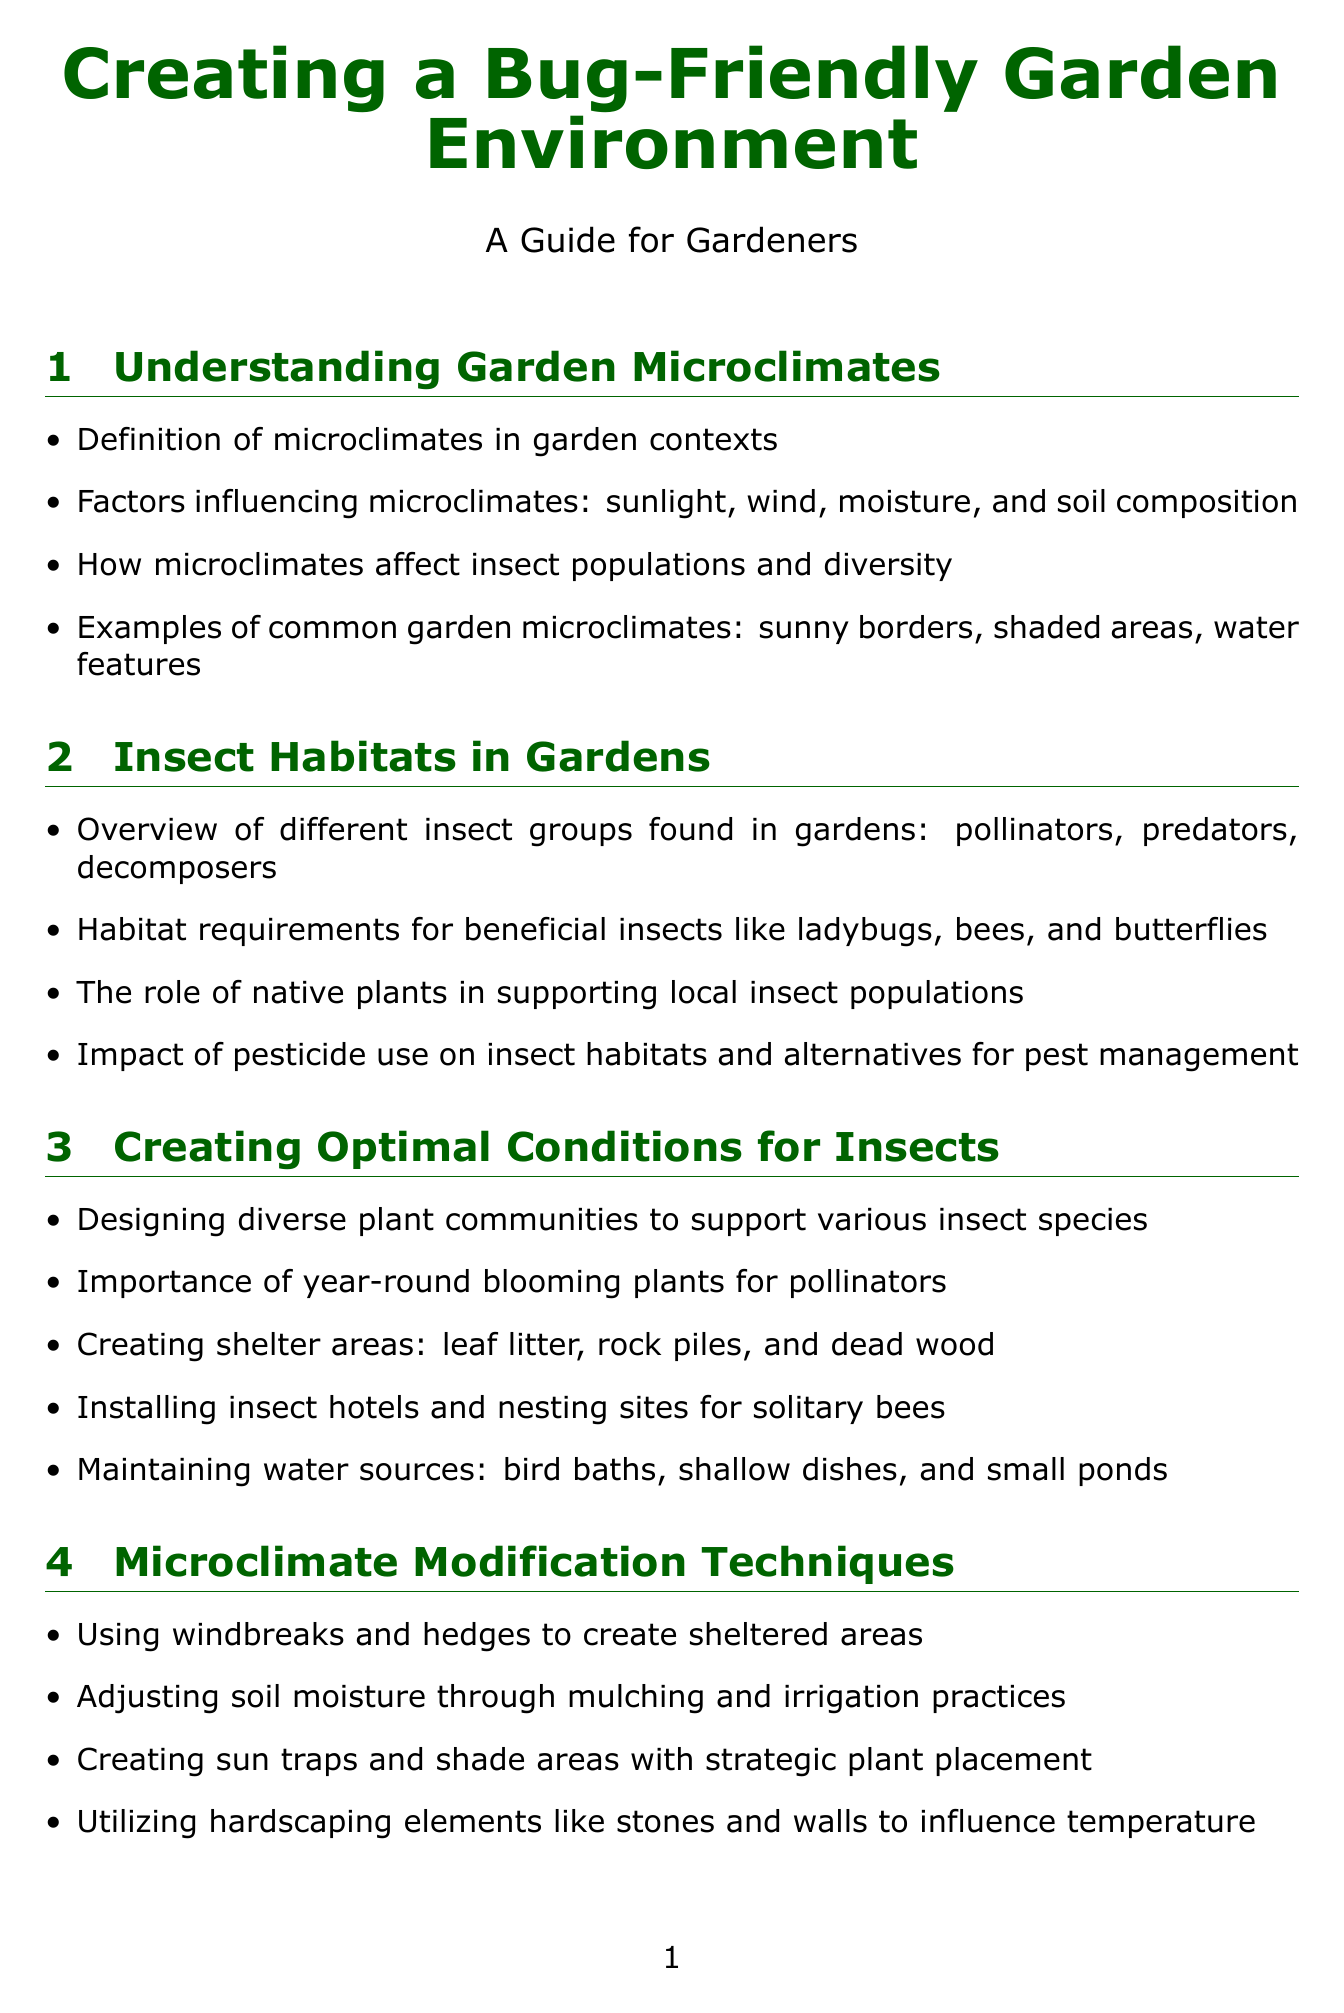What is defined in the report regarding garden microclimates? The report defines microclimates in garden contexts and discusses factors influencing them, such as sunlight, wind, moisture, and soil composition.
Answer: Definition of microclimates in garden contexts Which insects are categorized as decomposers? The document provides an overview of different insect groups found in gardens, including pollinators, predators, and decomposers.
Answer: Decomposers Name one tool recommended for monitoring soil acidity. The report lists tools for monitoring garden conditions, specifically mentioning the Soil pH Meter for monitoring soil acidity for optimal plant and insect habitat.
Answer: Soil pH Meter What is one method suggested for creating shelter areas for insects? The report includes methods for supporting insect habitats, such as creating shelter areas with leaf litter, rock piles, and dead wood.
Answer: Leaf litter What seasonal action is advised for spring? The document provides seasonal considerations, specifically suggesting to provide early nectar sources and nesting materials in spring.
Answer: Providing early nectar sources and nesting materials How can soil moisture be adjusted according to the report? Microclimate modification techniques include adjusting soil moisture through mulching and irrigation practices, as noted in the document.
Answer: Mulching and irrigation practices Which expert specializes in native plants and insect ecology? The report includes information about expert interviews, specifically noting Dr. Douglas Tallamy's expertise in native plants and insect ecology.
Answer: Dr. Douglas Tallamy What is one challenge in creating insect-friendly microclimates mentioned? The document addresses various challenges, one being balancing aesthetic preferences with insect habitat needs.
Answer: Balancing aesthetic preferences with insect habitat needs 